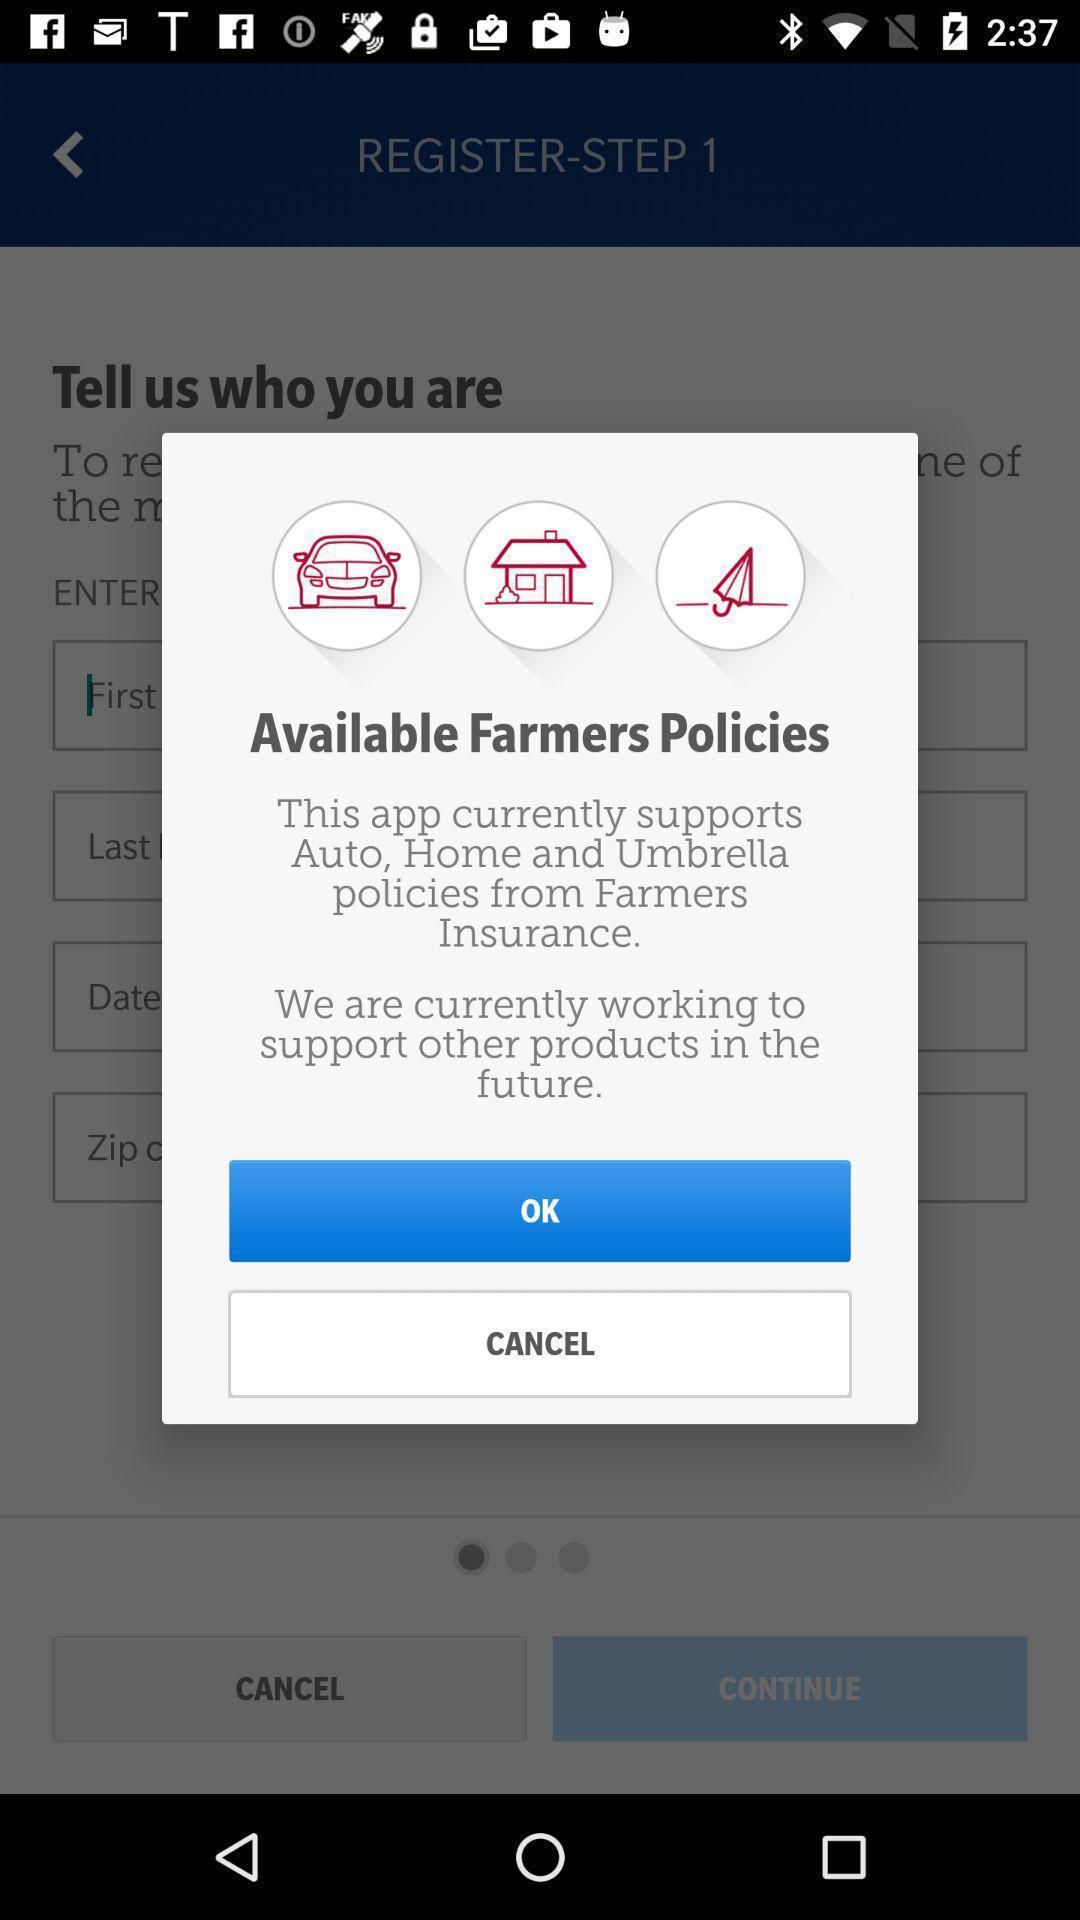Summarize the main components in this picture. Popup of the text regarding farmers policies. 